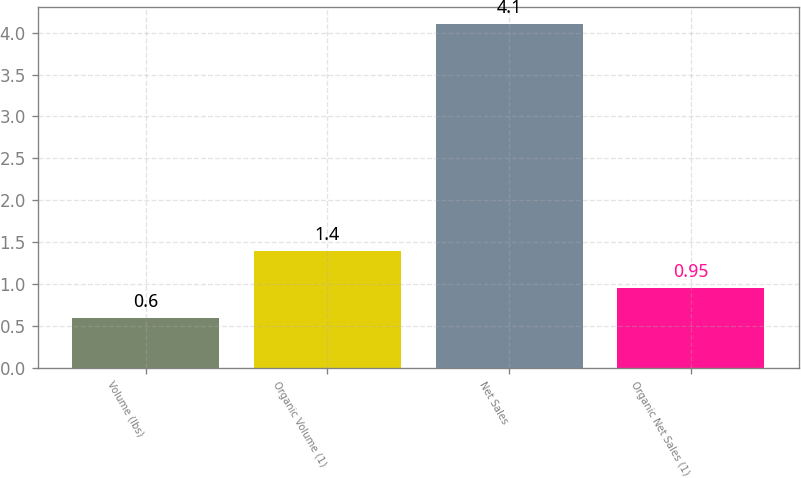Convert chart. <chart><loc_0><loc_0><loc_500><loc_500><bar_chart><fcel>Volume (lbs)<fcel>Organic Volume (1)<fcel>Net Sales<fcel>Organic Net Sales (1)<nl><fcel>0.6<fcel>1.4<fcel>4.1<fcel>0.95<nl></chart> 